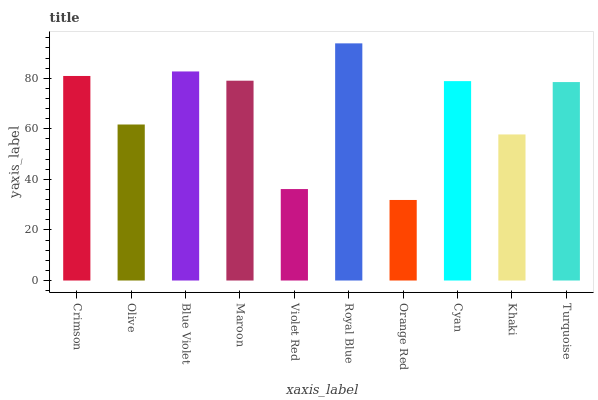Is Olive the minimum?
Answer yes or no. No. Is Olive the maximum?
Answer yes or no. No. Is Crimson greater than Olive?
Answer yes or no. Yes. Is Olive less than Crimson?
Answer yes or no. Yes. Is Olive greater than Crimson?
Answer yes or no. No. Is Crimson less than Olive?
Answer yes or no. No. Is Cyan the high median?
Answer yes or no. Yes. Is Turquoise the low median?
Answer yes or no. Yes. Is Maroon the high median?
Answer yes or no. No. Is Olive the low median?
Answer yes or no. No. 